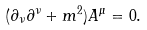<formula> <loc_0><loc_0><loc_500><loc_500>( \partial _ { \nu } \partial ^ { \nu } + m ^ { 2 } ) A ^ { \mu } = 0 .</formula> 